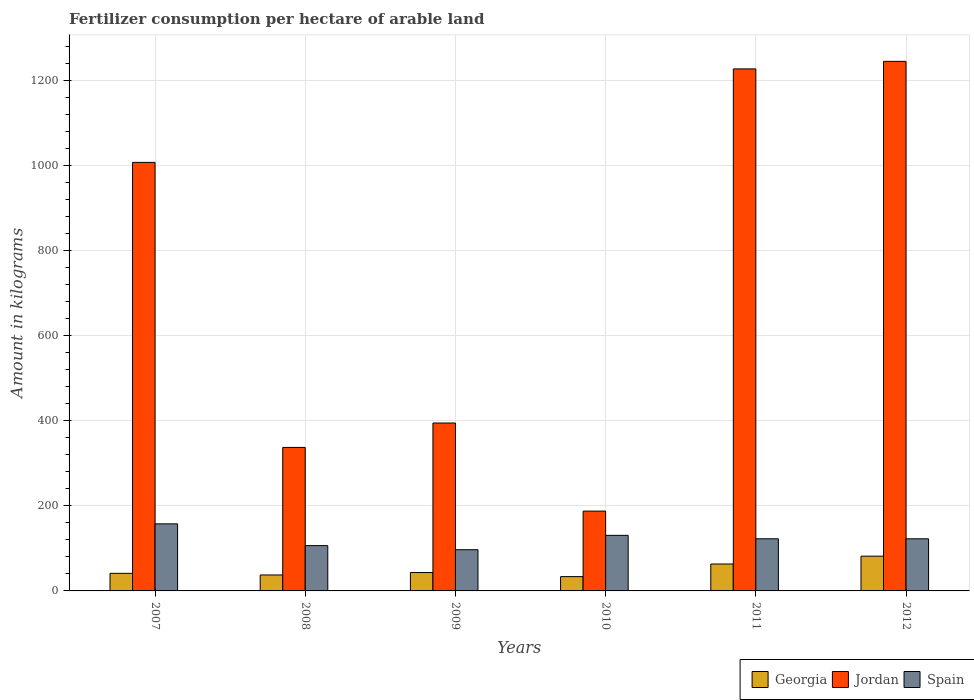How many different coloured bars are there?
Provide a succinct answer. 3. Are the number of bars per tick equal to the number of legend labels?
Offer a very short reply. Yes. How many bars are there on the 6th tick from the right?
Your response must be concise. 3. In how many cases, is the number of bars for a given year not equal to the number of legend labels?
Offer a very short reply. 0. What is the amount of fertilizer consumption in Spain in 2012?
Your answer should be compact. 122.58. Across all years, what is the maximum amount of fertilizer consumption in Jordan?
Your response must be concise. 1245.36. Across all years, what is the minimum amount of fertilizer consumption in Jordan?
Your response must be concise. 187.72. In which year was the amount of fertilizer consumption in Georgia maximum?
Offer a terse response. 2012. What is the total amount of fertilizer consumption in Jordan in the graph?
Keep it short and to the point. 4400.76. What is the difference between the amount of fertilizer consumption in Spain in 2009 and that in 2011?
Make the answer very short. -25.69. What is the difference between the amount of fertilizer consumption in Georgia in 2007 and the amount of fertilizer consumption in Spain in 2010?
Ensure brevity in your answer.  -89.34. What is the average amount of fertilizer consumption in Georgia per year?
Give a very brief answer. 50.13. In the year 2007, what is the difference between the amount of fertilizer consumption in Spain and amount of fertilizer consumption in Jordan?
Provide a succinct answer. -850.06. In how many years, is the amount of fertilizer consumption in Spain greater than 840 kg?
Provide a short and direct response. 0. What is the ratio of the amount of fertilizer consumption in Georgia in 2007 to that in 2009?
Offer a terse response. 0.96. Is the amount of fertilizer consumption in Georgia in 2011 less than that in 2012?
Offer a very short reply. Yes. Is the difference between the amount of fertilizer consumption in Spain in 2011 and 2012 greater than the difference between the amount of fertilizer consumption in Jordan in 2011 and 2012?
Offer a terse response. Yes. What is the difference between the highest and the second highest amount of fertilizer consumption in Jordan?
Keep it short and to the point. 17.77. What is the difference between the highest and the lowest amount of fertilizer consumption in Georgia?
Offer a terse response. 48.07. In how many years, is the amount of fertilizer consumption in Jordan greater than the average amount of fertilizer consumption in Jordan taken over all years?
Make the answer very short. 3. Is the sum of the amount of fertilizer consumption in Jordan in 2009 and 2011 greater than the maximum amount of fertilizer consumption in Spain across all years?
Give a very brief answer. Yes. What does the 1st bar from the left in 2010 represents?
Provide a short and direct response. Georgia. What does the 1st bar from the right in 2009 represents?
Offer a terse response. Spain. Is it the case that in every year, the sum of the amount of fertilizer consumption in Georgia and amount of fertilizer consumption in Spain is greater than the amount of fertilizer consumption in Jordan?
Your answer should be compact. No. Are all the bars in the graph horizontal?
Give a very brief answer. No. How many years are there in the graph?
Your answer should be compact. 6. Does the graph contain any zero values?
Provide a succinct answer. No. What is the title of the graph?
Your answer should be compact. Fertilizer consumption per hectare of arable land. Does "OECD members" appear as one of the legend labels in the graph?
Offer a very short reply. No. What is the label or title of the X-axis?
Give a very brief answer. Years. What is the label or title of the Y-axis?
Provide a short and direct response. Amount in kilograms. What is the Amount in kilograms in Georgia in 2007?
Provide a succinct answer. 41.34. What is the Amount in kilograms of Jordan in 2007?
Offer a very short reply. 1007.78. What is the Amount in kilograms in Spain in 2007?
Keep it short and to the point. 157.72. What is the Amount in kilograms of Georgia in 2008?
Offer a very short reply. 37.53. What is the Amount in kilograms in Jordan in 2008?
Your response must be concise. 337.44. What is the Amount in kilograms of Spain in 2008?
Keep it short and to the point. 106.54. What is the Amount in kilograms in Georgia in 2009?
Keep it short and to the point. 43.25. What is the Amount in kilograms of Jordan in 2009?
Ensure brevity in your answer.  394.86. What is the Amount in kilograms in Spain in 2009?
Provide a succinct answer. 96.93. What is the Amount in kilograms of Georgia in 2010?
Give a very brief answer. 33.65. What is the Amount in kilograms of Jordan in 2010?
Offer a terse response. 187.72. What is the Amount in kilograms of Spain in 2010?
Your answer should be compact. 130.68. What is the Amount in kilograms in Georgia in 2011?
Keep it short and to the point. 63.29. What is the Amount in kilograms of Jordan in 2011?
Offer a very short reply. 1227.59. What is the Amount in kilograms of Spain in 2011?
Your response must be concise. 122.62. What is the Amount in kilograms of Georgia in 2012?
Your response must be concise. 81.72. What is the Amount in kilograms of Jordan in 2012?
Provide a succinct answer. 1245.36. What is the Amount in kilograms in Spain in 2012?
Your answer should be very brief. 122.58. Across all years, what is the maximum Amount in kilograms of Georgia?
Offer a very short reply. 81.72. Across all years, what is the maximum Amount in kilograms in Jordan?
Offer a very short reply. 1245.36. Across all years, what is the maximum Amount in kilograms in Spain?
Keep it short and to the point. 157.72. Across all years, what is the minimum Amount in kilograms of Georgia?
Provide a succinct answer. 33.65. Across all years, what is the minimum Amount in kilograms in Jordan?
Your response must be concise. 187.72. Across all years, what is the minimum Amount in kilograms of Spain?
Your answer should be very brief. 96.93. What is the total Amount in kilograms of Georgia in the graph?
Your response must be concise. 300.78. What is the total Amount in kilograms in Jordan in the graph?
Provide a short and direct response. 4400.76. What is the total Amount in kilograms in Spain in the graph?
Your answer should be very brief. 737.07. What is the difference between the Amount in kilograms in Georgia in 2007 and that in 2008?
Provide a short and direct response. 3.81. What is the difference between the Amount in kilograms in Jordan in 2007 and that in 2008?
Provide a short and direct response. 670.34. What is the difference between the Amount in kilograms of Spain in 2007 and that in 2008?
Your answer should be compact. 51.18. What is the difference between the Amount in kilograms in Georgia in 2007 and that in 2009?
Provide a succinct answer. -1.91. What is the difference between the Amount in kilograms in Jordan in 2007 and that in 2009?
Your answer should be compact. 612.92. What is the difference between the Amount in kilograms of Spain in 2007 and that in 2009?
Provide a succinct answer. 60.8. What is the difference between the Amount in kilograms of Georgia in 2007 and that in 2010?
Provide a succinct answer. 7.69. What is the difference between the Amount in kilograms of Jordan in 2007 and that in 2010?
Your answer should be very brief. 820.06. What is the difference between the Amount in kilograms of Spain in 2007 and that in 2010?
Your response must be concise. 27.05. What is the difference between the Amount in kilograms in Georgia in 2007 and that in 2011?
Provide a short and direct response. -21.95. What is the difference between the Amount in kilograms in Jordan in 2007 and that in 2011?
Your response must be concise. -219.81. What is the difference between the Amount in kilograms of Spain in 2007 and that in 2011?
Give a very brief answer. 35.11. What is the difference between the Amount in kilograms of Georgia in 2007 and that in 2012?
Your answer should be compact. -40.38. What is the difference between the Amount in kilograms in Jordan in 2007 and that in 2012?
Give a very brief answer. -237.58. What is the difference between the Amount in kilograms in Spain in 2007 and that in 2012?
Your response must be concise. 35.14. What is the difference between the Amount in kilograms in Georgia in 2008 and that in 2009?
Your answer should be very brief. -5.72. What is the difference between the Amount in kilograms in Jordan in 2008 and that in 2009?
Your response must be concise. -57.42. What is the difference between the Amount in kilograms of Spain in 2008 and that in 2009?
Make the answer very short. 9.62. What is the difference between the Amount in kilograms in Georgia in 2008 and that in 2010?
Give a very brief answer. 3.88. What is the difference between the Amount in kilograms of Jordan in 2008 and that in 2010?
Make the answer very short. 149.73. What is the difference between the Amount in kilograms of Spain in 2008 and that in 2010?
Ensure brevity in your answer.  -24.13. What is the difference between the Amount in kilograms of Georgia in 2008 and that in 2011?
Your answer should be compact. -25.75. What is the difference between the Amount in kilograms of Jordan in 2008 and that in 2011?
Your answer should be very brief. -890.15. What is the difference between the Amount in kilograms of Spain in 2008 and that in 2011?
Your answer should be compact. -16.07. What is the difference between the Amount in kilograms in Georgia in 2008 and that in 2012?
Make the answer very short. -44.19. What is the difference between the Amount in kilograms of Jordan in 2008 and that in 2012?
Offer a very short reply. -907.91. What is the difference between the Amount in kilograms of Spain in 2008 and that in 2012?
Ensure brevity in your answer.  -16.04. What is the difference between the Amount in kilograms in Georgia in 2009 and that in 2010?
Ensure brevity in your answer.  9.59. What is the difference between the Amount in kilograms of Jordan in 2009 and that in 2010?
Provide a short and direct response. 207.14. What is the difference between the Amount in kilograms of Spain in 2009 and that in 2010?
Your answer should be compact. -33.75. What is the difference between the Amount in kilograms in Georgia in 2009 and that in 2011?
Keep it short and to the point. -20.04. What is the difference between the Amount in kilograms in Jordan in 2009 and that in 2011?
Your answer should be compact. -832.73. What is the difference between the Amount in kilograms in Spain in 2009 and that in 2011?
Keep it short and to the point. -25.69. What is the difference between the Amount in kilograms in Georgia in 2009 and that in 2012?
Provide a short and direct response. -38.47. What is the difference between the Amount in kilograms of Jordan in 2009 and that in 2012?
Provide a succinct answer. -850.5. What is the difference between the Amount in kilograms in Spain in 2009 and that in 2012?
Ensure brevity in your answer.  -25.65. What is the difference between the Amount in kilograms in Georgia in 2010 and that in 2011?
Provide a short and direct response. -29.63. What is the difference between the Amount in kilograms in Jordan in 2010 and that in 2011?
Offer a terse response. -1039.87. What is the difference between the Amount in kilograms in Spain in 2010 and that in 2011?
Make the answer very short. 8.06. What is the difference between the Amount in kilograms of Georgia in 2010 and that in 2012?
Offer a terse response. -48.07. What is the difference between the Amount in kilograms in Jordan in 2010 and that in 2012?
Offer a terse response. -1057.64. What is the difference between the Amount in kilograms of Spain in 2010 and that in 2012?
Your answer should be compact. 8.09. What is the difference between the Amount in kilograms in Georgia in 2011 and that in 2012?
Provide a short and direct response. -18.43. What is the difference between the Amount in kilograms of Jordan in 2011 and that in 2012?
Your answer should be compact. -17.77. What is the difference between the Amount in kilograms in Spain in 2011 and that in 2012?
Offer a very short reply. 0.04. What is the difference between the Amount in kilograms of Georgia in 2007 and the Amount in kilograms of Jordan in 2008?
Make the answer very short. -296.11. What is the difference between the Amount in kilograms of Georgia in 2007 and the Amount in kilograms of Spain in 2008?
Keep it short and to the point. -65.21. What is the difference between the Amount in kilograms of Jordan in 2007 and the Amount in kilograms of Spain in 2008?
Offer a terse response. 901.24. What is the difference between the Amount in kilograms of Georgia in 2007 and the Amount in kilograms of Jordan in 2009?
Make the answer very short. -353.52. What is the difference between the Amount in kilograms in Georgia in 2007 and the Amount in kilograms in Spain in 2009?
Your response must be concise. -55.59. What is the difference between the Amount in kilograms in Jordan in 2007 and the Amount in kilograms in Spain in 2009?
Give a very brief answer. 910.86. What is the difference between the Amount in kilograms of Georgia in 2007 and the Amount in kilograms of Jordan in 2010?
Your answer should be compact. -146.38. What is the difference between the Amount in kilograms of Georgia in 2007 and the Amount in kilograms of Spain in 2010?
Your response must be concise. -89.34. What is the difference between the Amount in kilograms in Jordan in 2007 and the Amount in kilograms in Spain in 2010?
Offer a very short reply. 877.11. What is the difference between the Amount in kilograms in Georgia in 2007 and the Amount in kilograms in Jordan in 2011?
Your answer should be very brief. -1186.25. What is the difference between the Amount in kilograms of Georgia in 2007 and the Amount in kilograms of Spain in 2011?
Ensure brevity in your answer.  -81.28. What is the difference between the Amount in kilograms in Jordan in 2007 and the Amount in kilograms in Spain in 2011?
Your answer should be very brief. 885.17. What is the difference between the Amount in kilograms of Georgia in 2007 and the Amount in kilograms of Jordan in 2012?
Provide a short and direct response. -1204.02. What is the difference between the Amount in kilograms of Georgia in 2007 and the Amount in kilograms of Spain in 2012?
Offer a very short reply. -81.24. What is the difference between the Amount in kilograms of Jordan in 2007 and the Amount in kilograms of Spain in 2012?
Offer a terse response. 885.2. What is the difference between the Amount in kilograms of Georgia in 2008 and the Amount in kilograms of Jordan in 2009?
Offer a very short reply. -357.33. What is the difference between the Amount in kilograms of Georgia in 2008 and the Amount in kilograms of Spain in 2009?
Provide a succinct answer. -59.4. What is the difference between the Amount in kilograms in Jordan in 2008 and the Amount in kilograms in Spain in 2009?
Keep it short and to the point. 240.52. What is the difference between the Amount in kilograms of Georgia in 2008 and the Amount in kilograms of Jordan in 2010?
Ensure brevity in your answer.  -150.19. What is the difference between the Amount in kilograms of Georgia in 2008 and the Amount in kilograms of Spain in 2010?
Give a very brief answer. -93.14. What is the difference between the Amount in kilograms of Jordan in 2008 and the Amount in kilograms of Spain in 2010?
Offer a very short reply. 206.77. What is the difference between the Amount in kilograms in Georgia in 2008 and the Amount in kilograms in Jordan in 2011?
Make the answer very short. -1190.06. What is the difference between the Amount in kilograms in Georgia in 2008 and the Amount in kilograms in Spain in 2011?
Your response must be concise. -85.08. What is the difference between the Amount in kilograms of Jordan in 2008 and the Amount in kilograms of Spain in 2011?
Ensure brevity in your answer.  214.83. What is the difference between the Amount in kilograms in Georgia in 2008 and the Amount in kilograms in Jordan in 2012?
Your response must be concise. -1207.83. What is the difference between the Amount in kilograms of Georgia in 2008 and the Amount in kilograms of Spain in 2012?
Make the answer very short. -85.05. What is the difference between the Amount in kilograms in Jordan in 2008 and the Amount in kilograms in Spain in 2012?
Provide a short and direct response. 214.86. What is the difference between the Amount in kilograms of Georgia in 2009 and the Amount in kilograms of Jordan in 2010?
Keep it short and to the point. -144.47. What is the difference between the Amount in kilograms in Georgia in 2009 and the Amount in kilograms in Spain in 2010?
Your answer should be compact. -87.43. What is the difference between the Amount in kilograms in Jordan in 2009 and the Amount in kilograms in Spain in 2010?
Offer a terse response. 264.19. What is the difference between the Amount in kilograms of Georgia in 2009 and the Amount in kilograms of Jordan in 2011?
Ensure brevity in your answer.  -1184.34. What is the difference between the Amount in kilograms of Georgia in 2009 and the Amount in kilograms of Spain in 2011?
Ensure brevity in your answer.  -79.37. What is the difference between the Amount in kilograms in Jordan in 2009 and the Amount in kilograms in Spain in 2011?
Make the answer very short. 272.24. What is the difference between the Amount in kilograms of Georgia in 2009 and the Amount in kilograms of Jordan in 2012?
Provide a short and direct response. -1202.11. What is the difference between the Amount in kilograms in Georgia in 2009 and the Amount in kilograms in Spain in 2012?
Provide a succinct answer. -79.33. What is the difference between the Amount in kilograms of Jordan in 2009 and the Amount in kilograms of Spain in 2012?
Provide a short and direct response. 272.28. What is the difference between the Amount in kilograms of Georgia in 2010 and the Amount in kilograms of Jordan in 2011?
Give a very brief answer. -1193.94. What is the difference between the Amount in kilograms of Georgia in 2010 and the Amount in kilograms of Spain in 2011?
Your answer should be very brief. -88.96. What is the difference between the Amount in kilograms of Jordan in 2010 and the Amount in kilograms of Spain in 2011?
Make the answer very short. 65.1. What is the difference between the Amount in kilograms of Georgia in 2010 and the Amount in kilograms of Jordan in 2012?
Make the answer very short. -1211.71. What is the difference between the Amount in kilograms of Georgia in 2010 and the Amount in kilograms of Spain in 2012?
Keep it short and to the point. -88.93. What is the difference between the Amount in kilograms in Jordan in 2010 and the Amount in kilograms in Spain in 2012?
Ensure brevity in your answer.  65.14. What is the difference between the Amount in kilograms in Georgia in 2011 and the Amount in kilograms in Jordan in 2012?
Keep it short and to the point. -1182.07. What is the difference between the Amount in kilograms in Georgia in 2011 and the Amount in kilograms in Spain in 2012?
Your answer should be compact. -59.3. What is the difference between the Amount in kilograms in Jordan in 2011 and the Amount in kilograms in Spain in 2012?
Keep it short and to the point. 1105.01. What is the average Amount in kilograms in Georgia per year?
Offer a very short reply. 50.13. What is the average Amount in kilograms of Jordan per year?
Provide a succinct answer. 733.46. What is the average Amount in kilograms in Spain per year?
Offer a very short reply. 122.84. In the year 2007, what is the difference between the Amount in kilograms of Georgia and Amount in kilograms of Jordan?
Ensure brevity in your answer.  -966.44. In the year 2007, what is the difference between the Amount in kilograms in Georgia and Amount in kilograms in Spain?
Your response must be concise. -116.38. In the year 2007, what is the difference between the Amount in kilograms in Jordan and Amount in kilograms in Spain?
Make the answer very short. 850.06. In the year 2008, what is the difference between the Amount in kilograms of Georgia and Amount in kilograms of Jordan?
Provide a short and direct response. -299.91. In the year 2008, what is the difference between the Amount in kilograms of Georgia and Amount in kilograms of Spain?
Keep it short and to the point. -69.01. In the year 2008, what is the difference between the Amount in kilograms of Jordan and Amount in kilograms of Spain?
Offer a terse response. 230.9. In the year 2009, what is the difference between the Amount in kilograms of Georgia and Amount in kilograms of Jordan?
Give a very brief answer. -351.61. In the year 2009, what is the difference between the Amount in kilograms in Georgia and Amount in kilograms in Spain?
Offer a very short reply. -53.68. In the year 2009, what is the difference between the Amount in kilograms of Jordan and Amount in kilograms of Spain?
Ensure brevity in your answer.  297.93. In the year 2010, what is the difference between the Amount in kilograms in Georgia and Amount in kilograms in Jordan?
Offer a terse response. -154.07. In the year 2010, what is the difference between the Amount in kilograms in Georgia and Amount in kilograms in Spain?
Give a very brief answer. -97.02. In the year 2010, what is the difference between the Amount in kilograms in Jordan and Amount in kilograms in Spain?
Offer a terse response. 57.04. In the year 2011, what is the difference between the Amount in kilograms of Georgia and Amount in kilograms of Jordan?
Your response must be concise. -1164.31. In the year 2011, what is the difference between the Amount in kilograms of Georgia and Amount in kilograms of Spain?
Keep it short and to the point. -59.33. In the year 2011, what is the difference between the Amount in kilograms of Jordan and Amount in kilograms of Spain?
Offer a very short reply. 1104.97. In the year 2012, what is the difference between the Amount in kilograms of Georgia and Amount in kilograms of Jordan?
Keep it short and to the point. -1163.64. In the year 2012, what is the difference between the Amount in kilograms in Georgia and Amount in kilograms in Spain?
Provide a short and direct response. -40.86. In the year 2012, what is the difference between the Amount in kilograms of Jordan and Amount in kilograms of Spain?
Ensure brevity in your answer.  1122.78. What is the ratio of the Amount in kilograms in Georgia in 2007 to that in 2008?
Provide a succinct answer. 1.1. What is the ratio of the Amount in kilograms of Jordan in 2007 to that in 2008?
Your response must be concise. 2.99. What is the ratio of the Amount in kilograms in Spain in 2007 to that in 2008?
Give a very brief answer. 1.48. What is the ratio of the Amount in kilograms in Georgia in 2007 to that in 2009?
Your answer should be very brief. 0.96. What is the ratio of the Amount in kilograms in Jordan in 2007 to that in 2009?
Provide a short and direct response. 2.55. What is the ratio of the Amount in kilograms of Spain in 2007 to that in 2009?
Offer a very short reply. 1.63. What is the ratio of the Amount in kilograms of Georgia in 2007 to that in 2010?
Your answer should be very brief. 1.23. What is the ratio of the Amount in kilograms in Jordan in 2007 to that in 2010?
Keep it short and to the point. 5.37. What is the ratio of the Amount in kilograms of Spain in 2007 to that in 2010?
Make the answer very short. 1.21. What is the ratio of the Amount in kilograms of Georgia in 2007 to that in 2011?
Provide a succinct answer. 0.65. What is the ratio of the Amount in kilograms in Jordan in 2007 to that in 2011?
Your answer should be compact. 0.82. What is the ratio of the Amount in kilograms in Spain in 2007 to that in 2011?
Keep it short and to the point. 1.29. What is the ratio of the Amount in kilograms in Georgia in 2007 to that in 2012?
Make the answer very short. 0.51. What is the ratio of the Amount in kilograms in Jordan in 2007 to that in 2012?
Ensure brevity in your answer.  0.81. What is the ratio of the Amount in kilograms of Spain in 2007 to that in 2012?
Offer a terse response. 1.29. What is the ratio of the Amount in kilograms in Georgia in 2008 to that in 2009?
Ensure brevity in your answer.  0.87. What is the ratio of the Amount in kilograms in Jordan in 2008 to that in 2009?
Ensure brevity in your answer.  0.85. What is the ratio of the Amount in kilograms in Spain in 2008 to that in 2009?
Your answer should be compact. 1.1. What is the ratio of the Amount in kilograms of Georgia in 2008 to that in 2010?
Provide a succinct answer. 1.12. What is the ratio of the Amount in kilograms in Jordan in 2008 to that in 2010?
Offer a very short reply. 1.8. What is the ratio of the Amount in kilograms of Spain in 2008 to that in 2010?
Offer a terse response. 0.82. What is the ratio of the Amount in kilograms in Georgia in 2008 to that in 2011?
Keep it short and to the point. 0.59. What is the ratio of the Amount in kilograms of Jordan in 2008 to that in 2011?
Ensure brevity in your answer.  0.27. What is the ratio of the Amount in kilograms of Spain in 2008 to that in 2011?
Make the answer very short. 0.87. What is the ratio of the Amount in kilograms in Georgia in 2008 to that in 2012?
Provide a succinct answer. 0.46. What is the ratio of the Amount in kilograms of Jordan in 2008 to that in 2012?
Give a very brief answer. 0.27. What is the ratio of the Amount in kilograms of Spain in 2008 to that in 2012?
Your answer should be compact. 0.87. What is the ratio of the Amount in kilograms in Georgia in 2009 to that in 2010?
Offer a very short reply. 1.29. What is the ratio of the Amount in kilograms of Jordan in 2009 to that in 2010?
Your answer should be compact. 2.1. What is the ratio of the Amount in kilograms in Spain in 2009 to that in 2010?
Your answer should be very brief. 0.74. What is the ratio of the Amount in kilograms of Georgia in 2009 to that in 2011?
Provide a succinct answer. 0.68. What is the ratio of the Amount in kilograms of Jordan in 2009 to that in 2011?
Make the answer very short. 0.32. What is the ratio of the Amount in kilograms in Spain in 2009 to that in 2011?
Offer a terse response. 0.79. What is the ratio of the Amount in kilograms of Georgia in 2009 to that in 2012?
Offer a terse response. 0.53. What is the ratio of the Amount in kilograms of Jordan in 2009 to that in 2012?
Offer a very short reply. 0.32. What is the ratio of the Amount in kilograms of Spain in 2009 to that in 2012?
Offer a terse response. 0.79. What is the ratio of the Amount in kilograms in Georgia in 2010 to that in 2011?
Offer a terse response. 0.53. What is the ratio of the Amount in kilograms in Jordan in 2010 to that in 2011?
Your response must be concise. 0.15. What is the ratio of the Amount in kilograms of Spain in 2010 to that in 2011?
Your answer should be very brief. 1.07. What is the ratio of the Amount in kilograms in Georgia in 2010 to that in 2012?
Give a very brief answer. 0.41. What is the ratio of the Amount in kilograms in Jordan in 2010 to that in 2012?
Ensure brevity in your answer.  0.15. What is the ratio of the Amount in kilograms of Spain in 2010 to that in 2012?
Give a very brief answer. 1.07. What is the ratio of the Amount in kilograms of Georgia in 2011 to that in 2012?
Your answer should be compact. 0.77. What is the ratio of the Amount in kilograms in Jordan in 2011 to that in 2012?
Keep it short and to the point. 0.99. What is the ratio of the Amount in kilograms of Spain in 2011 to that in 2012?
Your answer should be compact. 1. What is the difference between the highest and the second highest Amount in kilograms of Georgia?
Provide a succinct answer. 18.43. What is the difference between the highest and the second highest Amount in kilograms of Jordan?
Keep it short and to the point. 17.77. What is the difference between the highest and the second highest Amount in kilograms of Spain?
Your answer should be compact. 27.05. What is the difference between the highest and the lowest Amount in kilograms in Georgia?
Offer a very short reply. 48.07. What is the difference between the highest and the lowest Amount in kilograms in Jordan?
Your response must be concise. 1057.64. What is the difference between the highest and the lowest Amount in kilograms in Spain?
Offer a terse response. 60.8. 